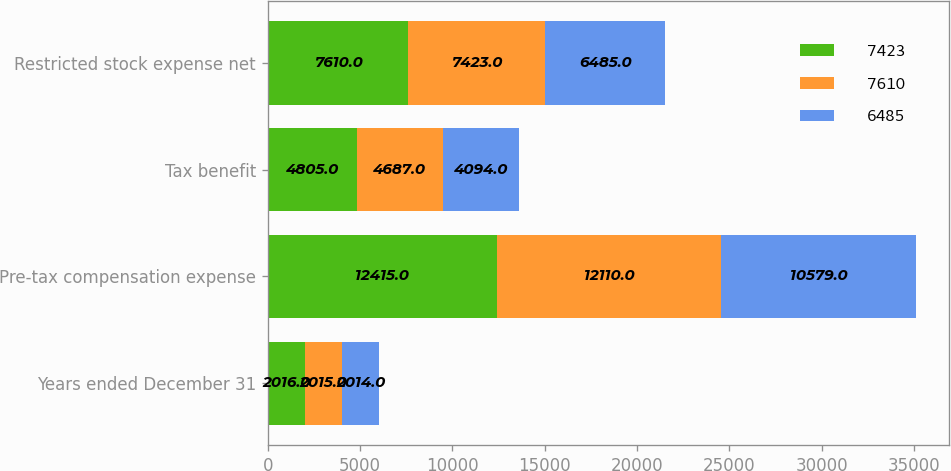Convert chart to OTSL. <chart><loc_0><loc_0><loc_500><loc_500><stacked_bar_chart><ecel><fcel>Years ended December 31<fcel>Pre-tax compensation expense<fcel>Tax benefit<fcel>Restricted stock expense net<nl><fcel>7423<fcel>2016<fcel>12415<fcel>4805<fcel>7610<nl><fcel>7610<fcel>2015<fcel>12110<fcel>4687<fcel>7423<nl><fcel>6485<fcel>2014<fcel>10579<fcel>4094<fcel>6485<nl></chart> 